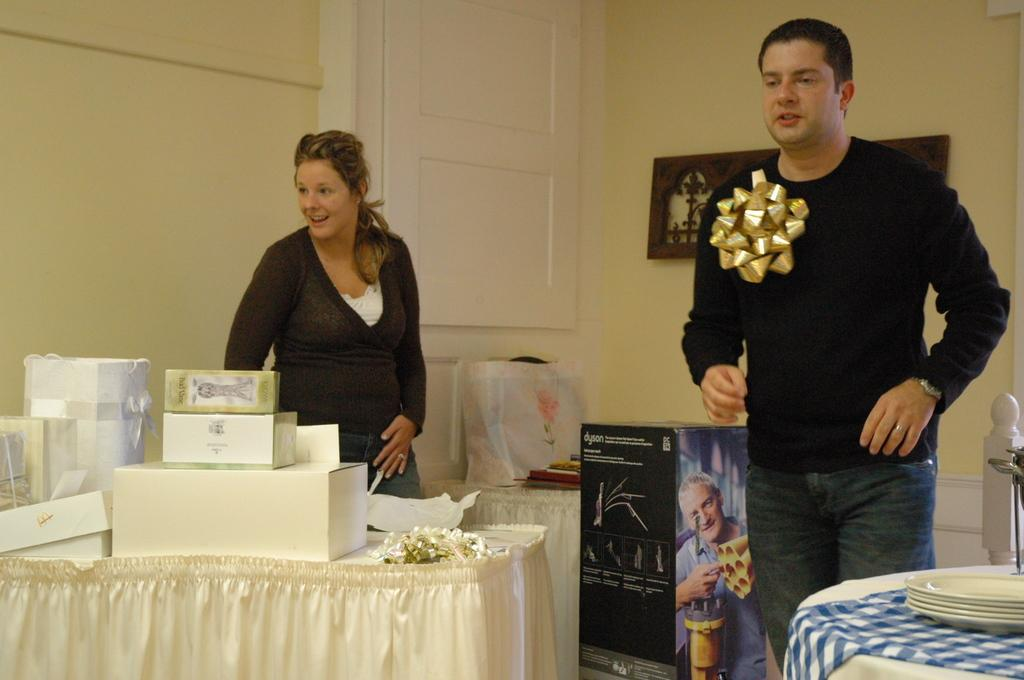Who is present in the image? There is a couple in the image. What are the couple doing in the image? The couple is standing beside a table. What objects can be seen on the table? There are pack boxes on the table. What type of jelly is being used in the competition in the image? There is no competition or jelly present in the image. Can you see the couple's shoes in the image? The image does not show the couple's shoes, only their legs and the table they are standing beside. 